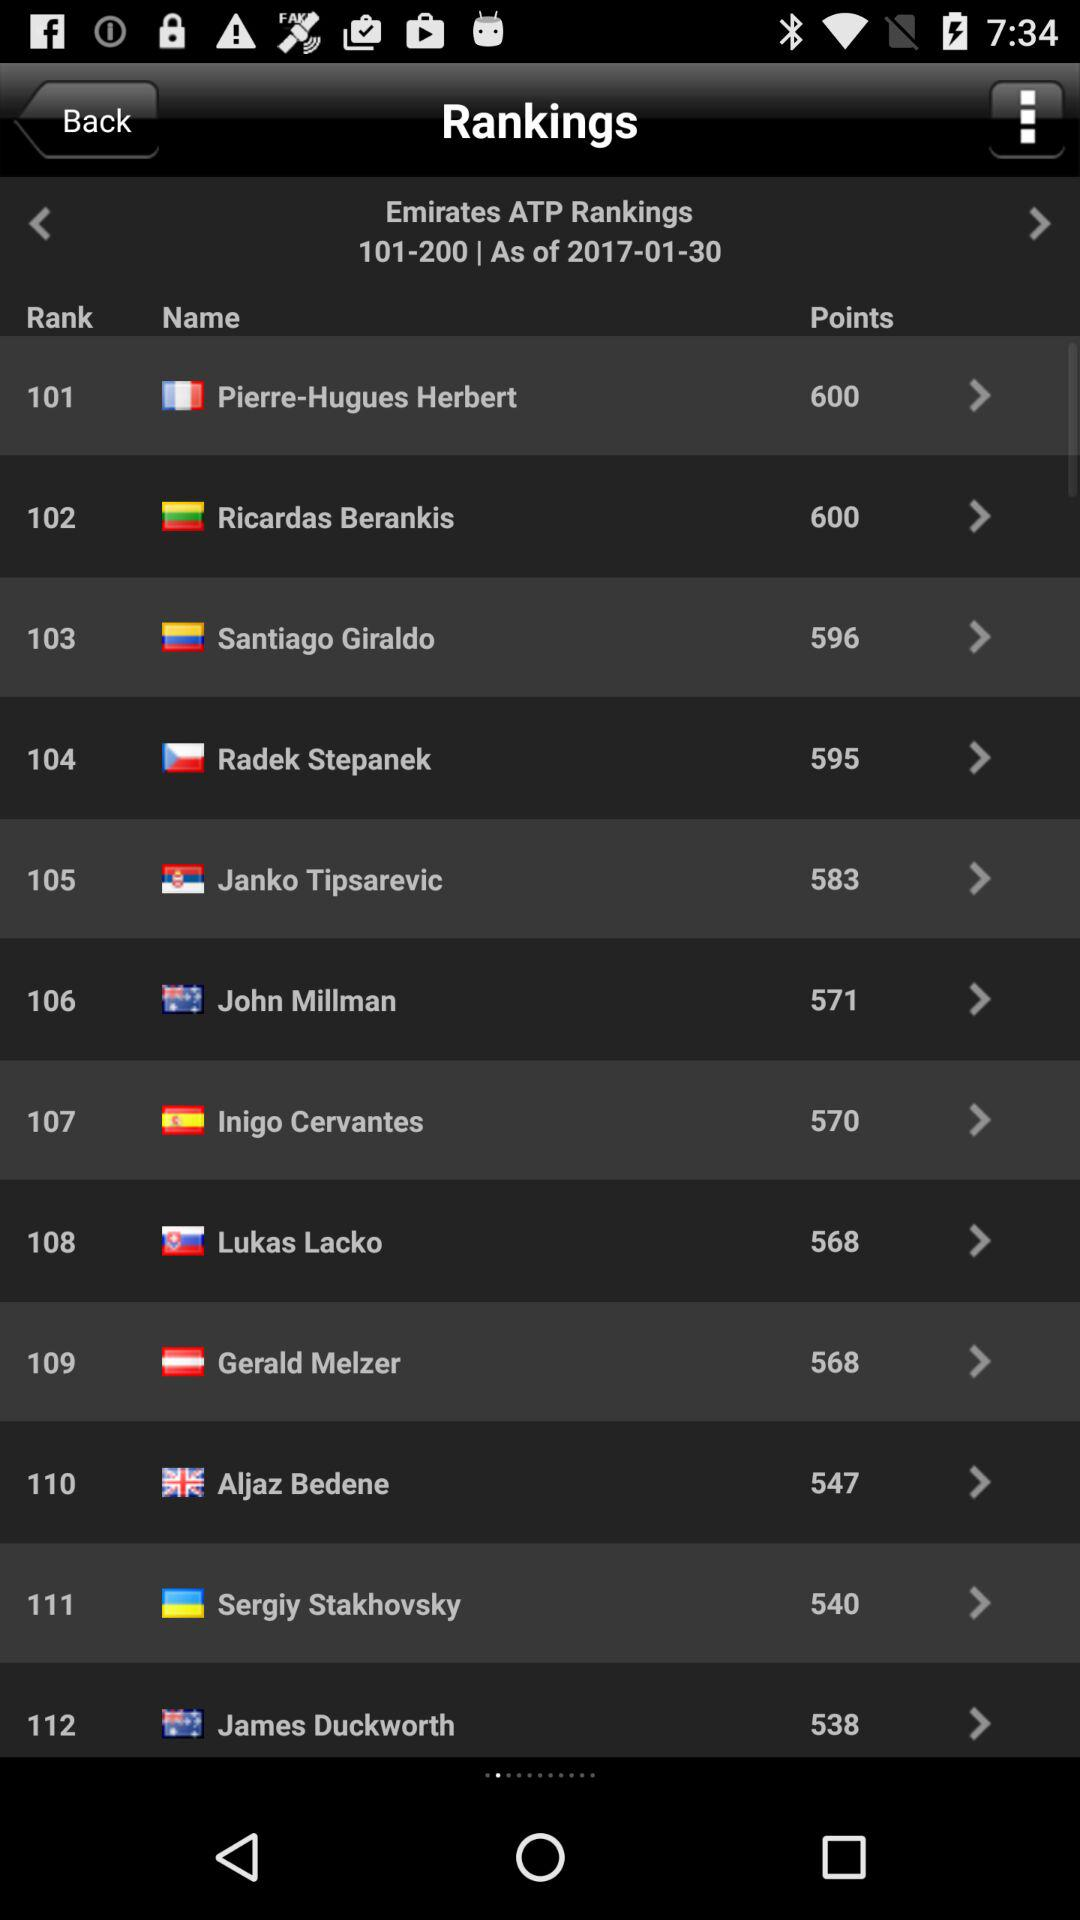What is the rank of Pierre-Hugues Herbert? The rank of Pierre-Hugues Herbert is 101. 